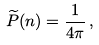Convert formula to latex. <formula><loc_0><loc_0><loc_500><loc_500>\widetilde { P } ( { n } ) = \frac { 1 } { 4 \pi } \, ,</formula> 